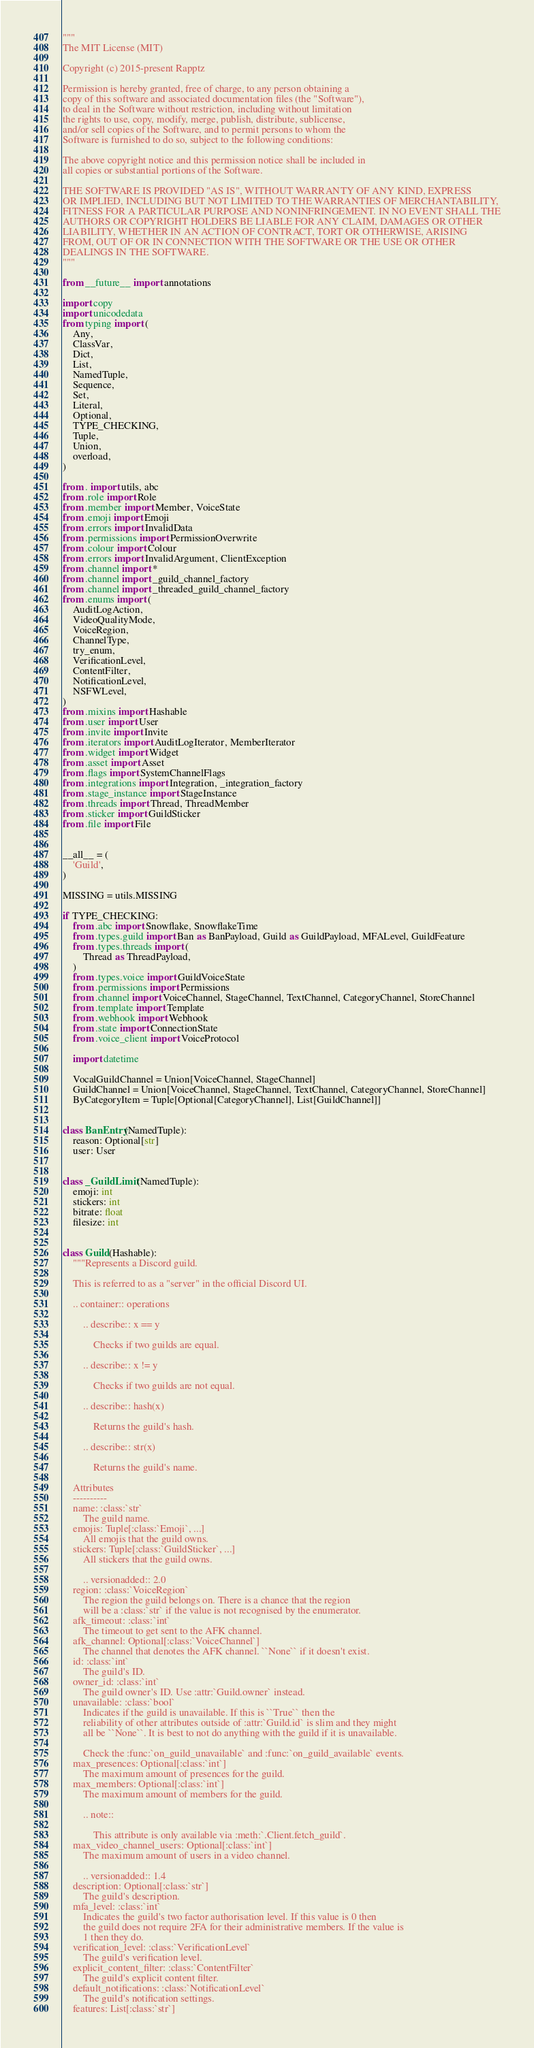<code> <loc_0><loc_0><loc_500><loc_500><_Python_>"""
The MIT License (MIT)

Copyright (c) 2015-present Rapptz

Permission is hereby granted, free of charge, to any person obtaining a
copy of this software and associated documentation files (the "Software"),
to deal in the Software without restriction, including without limitation
the rights to use, copy, modify, merge, publish, distribute, sublicense,
and/or sell copies of the Software, and to permit persons to whom the
Software is furnished to do so, subject to the following conditions:

The above copyright notice and this permission notice shall be included in
all copies or substantial portions of the Software.

THE SOFTWARE IS PROVIDED "AS IS", WITHOUT WARRANTY OF ANY KIND, EXPRESS
OR IMPLIED, INCLUDING BUT NOT LIMITED TO THE WARRANTIES OF MERCHANTABILITY,
FITNESS FOR A PARTICULAR PURPOSE AND NONINFRINGEMENT. IN NO EVENT SHALL THE
AUTHORS OR COPYRIGHT HOLDERS BE LIABLE FOR ANY CLAIM, DAMAGES OR OTHER
LIABILITY, WHETHER IN AN ACTION OF CONTRACT, TORT OR OTHERWISE, ARISING
FROM, OUT OF OR IN CONNECTION WITH THE SOFTWARE OR THE USE OR OTHER
DEALINGS IN THE SOFTWARE.
"""

from __future__ import annotations

import copy
import unicodedata
from typing import (
    Any,
    ClassVar,
    Dict,
    List,
    NamedTuple,
    Sequence,
    Set,
    Literal,
    Optional,
    TYPE_CHECKING,
    Tuple,
    Union,
    overload,
)

from . import utils, abc
from .role import Role
from .member import Member, VoiceState
from .emoji import Emoji
from .errors import InvalidData
from .permissions import PermissionOverwrite
from .colour import Colour
from .errors import InvalidArgument, ClientException
from .channel import *
from .channel import _guild_channel_factory
from .channel import _threaded_guild_channel_factory
from .enums import (
    AuditLogAction,
    VideoQualityMode,
    VoiceRegion,
    ChannelType,
    try_enum,
    VerificationLevel,
    ContentFilter,
    NotificationLevel,
    NSFWLevel,
)
from .mixins import Hashable
from .user import User
from .invite import Invite
from .iterators import AuditLogIterator, MemberIterator
from .widget import Widget
from .asset import Asset
from .flags import SystemChannelFlags
from .integrations import Integration, _integration_factory
from .stage_instance import StageInstance
from .threads import Thread, ThreadMember
from .sticker import GuildSticker
from .file import File


__all__ = (
    'Guild',
)

MISSING = utils.MISSING

if TYPE_CHECKING:
    from .abc import Snowflake, SnowflakeTime
    from .types.guild import Ban as BanPayload, Guild as GuildPayload, MFALevel, GuildFeature
    from .types.threads import (
        Thread as ThreadPayload,
    )
    from .types.voice import GuildVoiceState
    from .permissions import Permissions
    from .channel import VoiceChannel, StageChannel, TextChannel, CategoryChannel, StoreChannel
    from .template import Template
    from .webhook import Webhook
    from .state import ConnectionState
    from .voice_client import VoiceProtocol

    import datetime

    VocalGuildChannel = Union[VoiceChannel, StageChannel]
    GuildChannel = Union[VoiceChannel, StageChannel, TextChannel, CategoryChannel, StoreChannel]
    ByCategoryItem = Tuple[Optional[CategoryChannel], List[GuildChannel]]


class BanEntry(NamedTuple):
    reason: Optional[str]
    user: User


class _GuildLimit(NamedTuple):
    emoji: int
    stickers: int
    bitrate: float
    filesize: int


class Guild(Hashable):
    """Represents a Discord guild.

    This is referred to as a "server" in the official Discord UI.

    .. container:: operations

        .. describe:: x == y

            Checks if two guilds are equal.

        .. describe:: x != y

            Checks if two guilds are not equal.

        .. describe:: hash(x)

            Returns the guild's hash.

        .. describe:: str(x)

            Returns the guild's name.

    Attributes
    ----------
    name: :class:`str`
        The guild name.
    emojis: Tuple[:class:`Emoji`, ...]
        All emojis that the guild owns.
    stickers: Tuple[:class:`GuildSticker`, ...]
        All stickers that the guild owns.

        .. versionadded:: 2.0
    region: :class:`VoiceRegion`
        The region the guild belongs on. There is a chance that the region
        will be a :class:`str` if the value is not recognised by the enumerator.
    afk_timeout: :class:`int`
        The timeout to get sent to the AFK channel.
    afk_channel: Optional[:class:`VoiceChannel`]
        The channel that denotes the AFK channel. ``None`` if it doesn't exist.
    id: :class:`int`
        The guild's ID.
    owner_id: :class:`int`
        The guild owner's ID. Use :attr:`Guild.owner` instead.
    unavailable: :class:`bool`
        Indicates if the guild is unavailable. If this is ``True`` then the
        reliability of other attributes outside of :attr:`Guild.id` is slim and they might
        all be ``None``. It is best to not do anything with the guild if it is unavailable.

        Check the :func:`on_guild_unavailable` and :func:`on_guild_available` events.
    max_presences: Optional[:class:`int`]
        The maximum amount of presences for the guild.
    max_members: Optional[:class:`int`]
        The maximum amount of members for the guild.

        .. note::

            This attribute is only available via :meth:`.Client.fetch_guild`.
    max_video_channel_users: Optional[:class:`int`]
        The maximum amount of users in a video channel.

        .. versionadded:: 1.4
    description: Optional[:class:`str`]
        The guild's description.
    mfa_level: :class:`int`
        Indicates the guild's two factor authorisation level. If this value is 0 then
        the guild does not require 2FA for their administrative members. If the value is
        1 then they do.
    verification_level: :class:`VerificationLevel`
        The guild's verification level.
    explicit_content_filter: :class:`ContentFilter`
        The guild's explicit content filter.
    default_notifications: :class:`NotificationLevel`
        The guild's notification settings.
    features: List[:class:`str`]</code> 